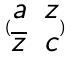Convert formula to latex. <formula><loc_0><loc_0><loc_500><loc_500>( \begin{matrix} a & z \\ \overline { z } & c \end{matrix} )</formula> 